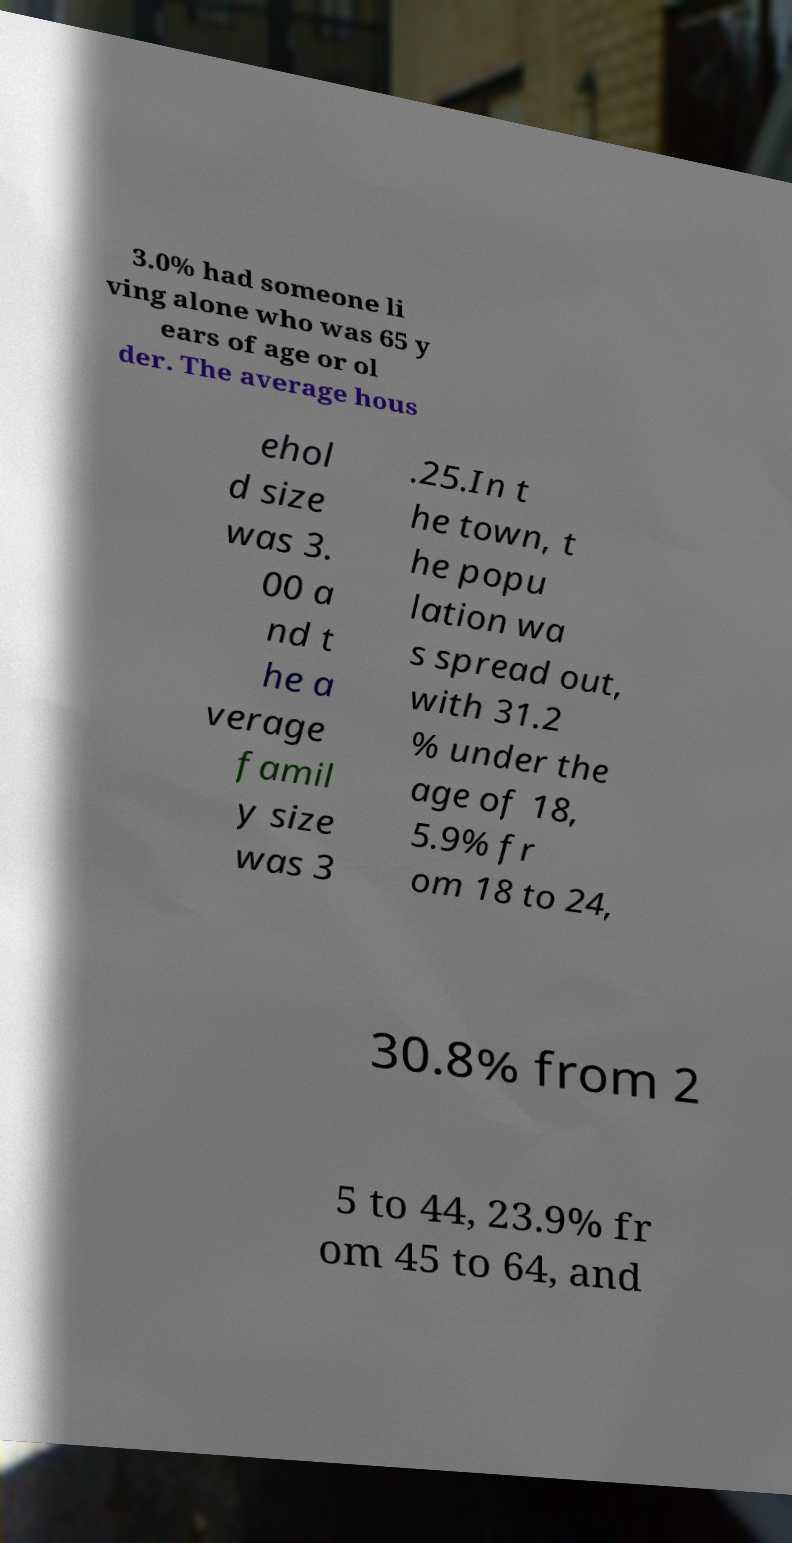Could you extract and type out the text from this image? 3.0% had someone li ving alone who was 65 y ears of age or ol der. The average hous ehol d size was 3. 00 a nd t he a verage famil y size was 3 .25.In t he town, t he popu lation wa s spread out, with 31.2 % under the age of 18, 5.9% fr om 18 to 24, 30.8% from 2 5 to 44, 23.9% fr om 45 to 64, and 